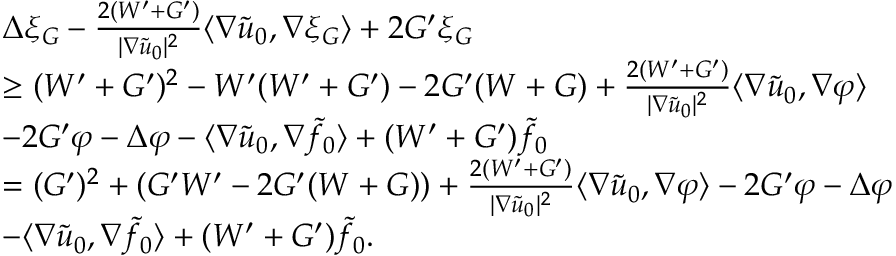Convert formula to latex. <formula><loc_0><loc_0><loc_500><loc_500>\begin{array} { r l } & { \Delta \xi _ { G } - \frac { 2 ( W ^ { \prime } + G ^ { \prime } ) } { | \nabla \tilde { u } _ { 0 } | ^ { 2 } } \langle \nabla \tilde { u } _ { 0 } , \nabla \xi _ { G } \rangle + 2 G ^ { \prime } \xi _ { G } } \\ & { \geq ( W ^ { \prime } + G ^ { \prime } ) ^ { 2 } - W ^ { \prime } ( W ^ { \prime } + G ^ { \prime } ) - 2 G ^ { \prime } ( W + G ) + \frac { 2 ( W ^ { \prime } + G ^ { \prime } ) } { | \nabla \tilde { u } _ { 0 } | ^ { 2 } } \langle \nabla \tilde { u } _ { 0 } , \nabla \varphi \rangle } \\ & { - 2 G ^ { \prime } \varphi - \Delta \varphi - \langle \nabla \tilde { u } _ { 0 } , \nabla \tilde { f } _ { 0 } \rangle + ( W ^ { \prime } + G ^ { \prime } ) \tilde { f } _ { 0 } } \\ & { = ( G ^ { \prime } ) ^ { 2 } + \left ( G ^ { \prime } W ^ { \prime } - 2 G ^ { \prime } ( W + G ) \right ) + \frac { 2 ( W ^ { \prime } + G ^ { \prime } ) } { | \nabla \tilde { u } _ { 0 } | ^ { 2 } } \langle \nabla \tilde { u } _ { 0 } , \nabla \varphi \rangle - 2 G ^ { \prime } \varphi - \Delta \varphi } \\ & { - \langle \nabla \tilde { u } _ { 0 } , \nabla \tilde { f } _ { 0 } \rangle + ( W ^ { \prime } + G ^ { \prime } ) \tilde { f } _ { 0 } . } \end{array}</formula> 